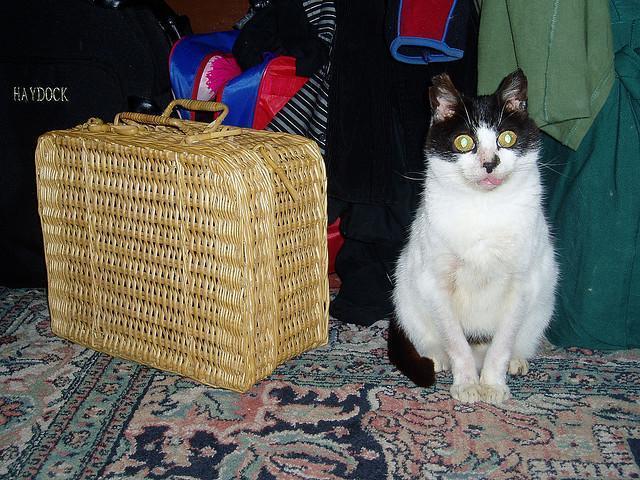How many cats are there?
Give a very brief answer. 1. How many suitcases are there?
Give a very brief answer. 2. 